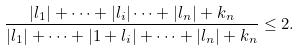Convert formula to latex. <formula><loc_0><loc_0><loc_500><loc_500>\frac { | l _ { 1 } | + \cdots + | l _ { i } | \cdots + | l _ { n } | + k _ { n } } { | l _ { 1 } | + \cdots + | 1 + l _ { i } | + \cdots + | l _ { n } | + k _ { n } } \leq 2 .</formula> 